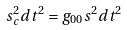Convert formula to latex. <formula><loc_0><loc_0><loc_500><loc_500>s _ { c } ^ { 2 } d t ^ { 2 } = g _ { 0 0 } s ^ { 2 } d t ^ { 2 }</formula> 